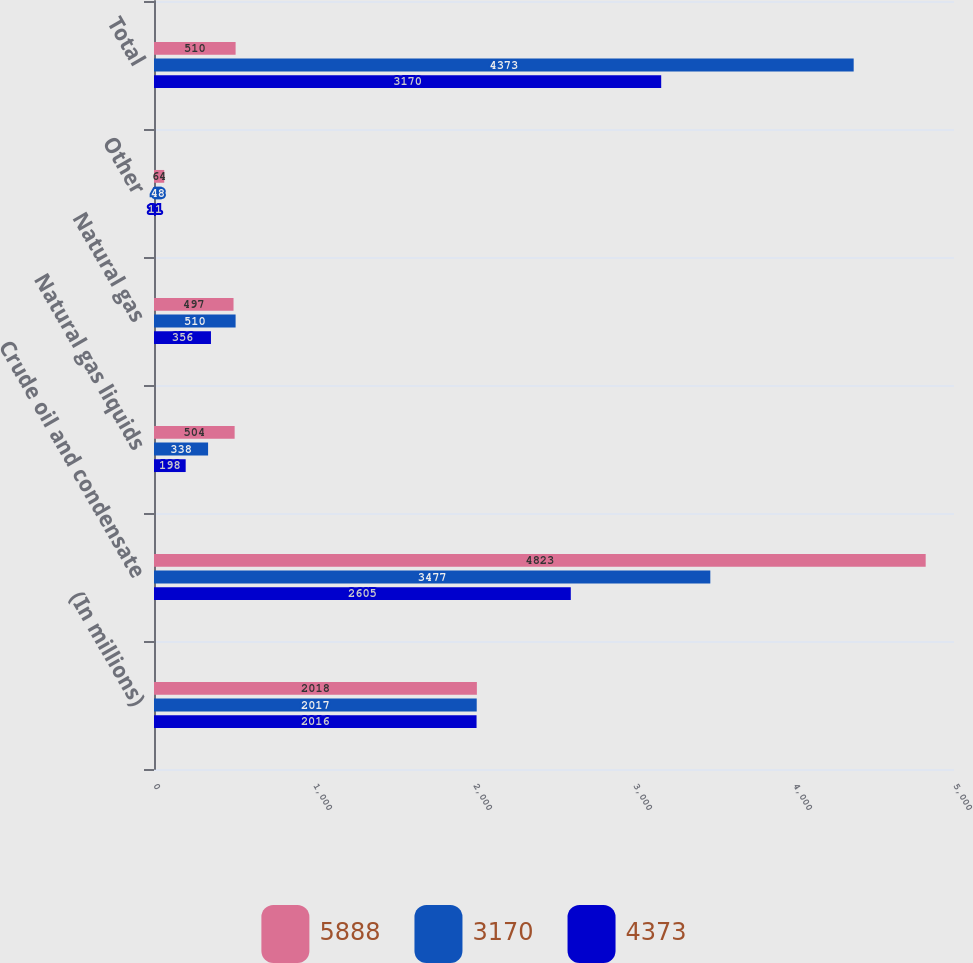Convert chart to OTSL. <chart><loc_0><loc_0><loc_500><loc_500><stacked_bar_chart><ecel><fcel>(In millions)<fcel>Crude oil and condensate<fcel>Natural gas liquids<fcel>Natural gas<fcel>Other<fcel>Total<nl><fcel>5888<fcel>2018<fcel>4823<fcel>504<fcel>497<fcel>64<fcel>510<nl><fcel>3170<fcel>2017<fcel>3477<fcel>338<fcel>510<fcel>48<fcel>4373<nl><fcel>4373<fcel>2016<fcel>2605<fcel>198<fcel>356<fcel>11<fcel>3170<nl></chart> 